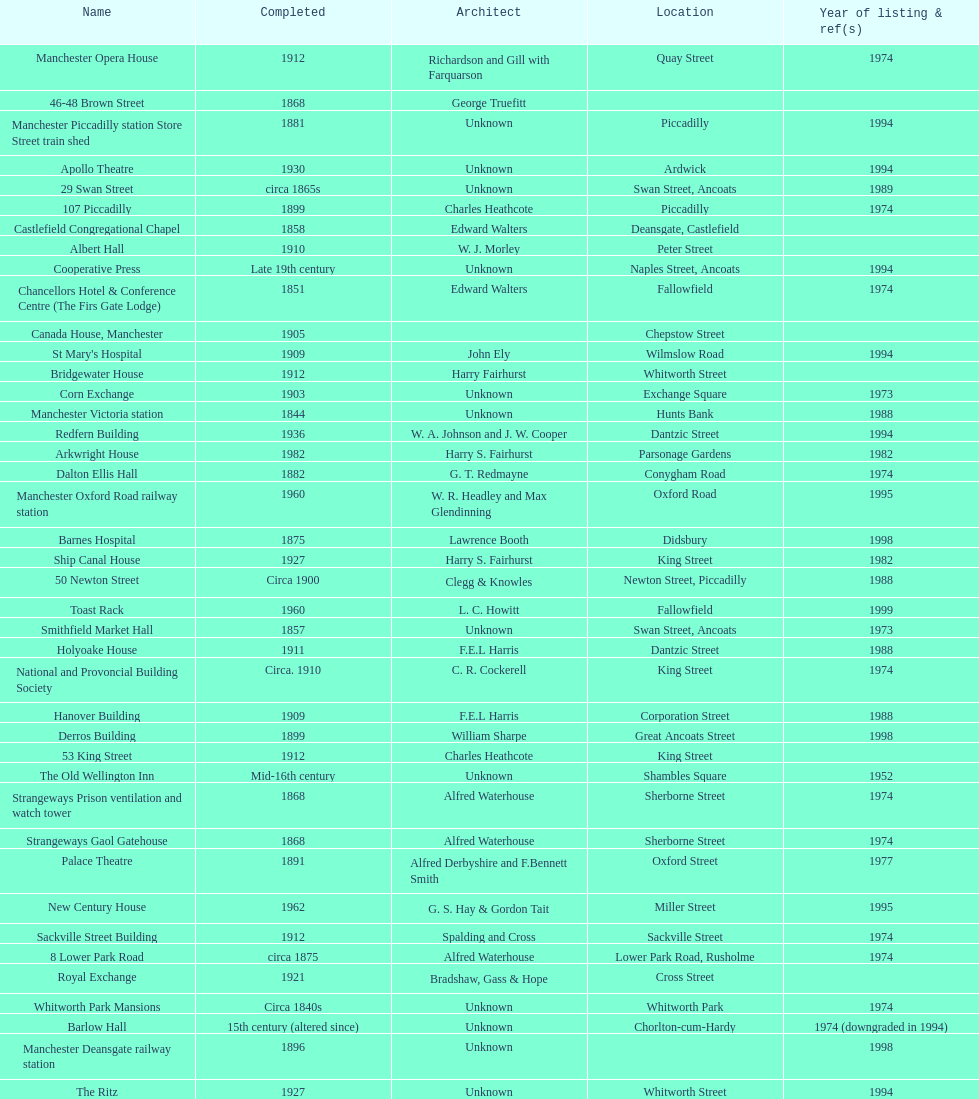How many names are listed with an image? 39. 